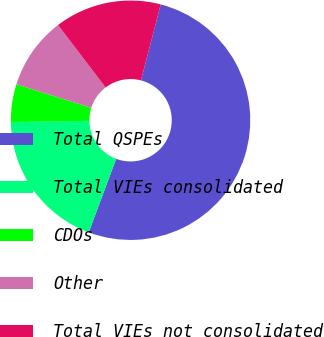Convert chart. <chart><loc_0><loc_0><loc_500><loc_500><pie_chart><fcel>Total QSPEs<fcel>Total VIEs consolidated<fcel>CDOs<fcel>Other<fcel>Total VIEs not consolidated<nl><fcel>51.63%<fcel>19.07%<fcel>5.11%<fcel>9.77%<fcel>14.42%<nl></chart> 